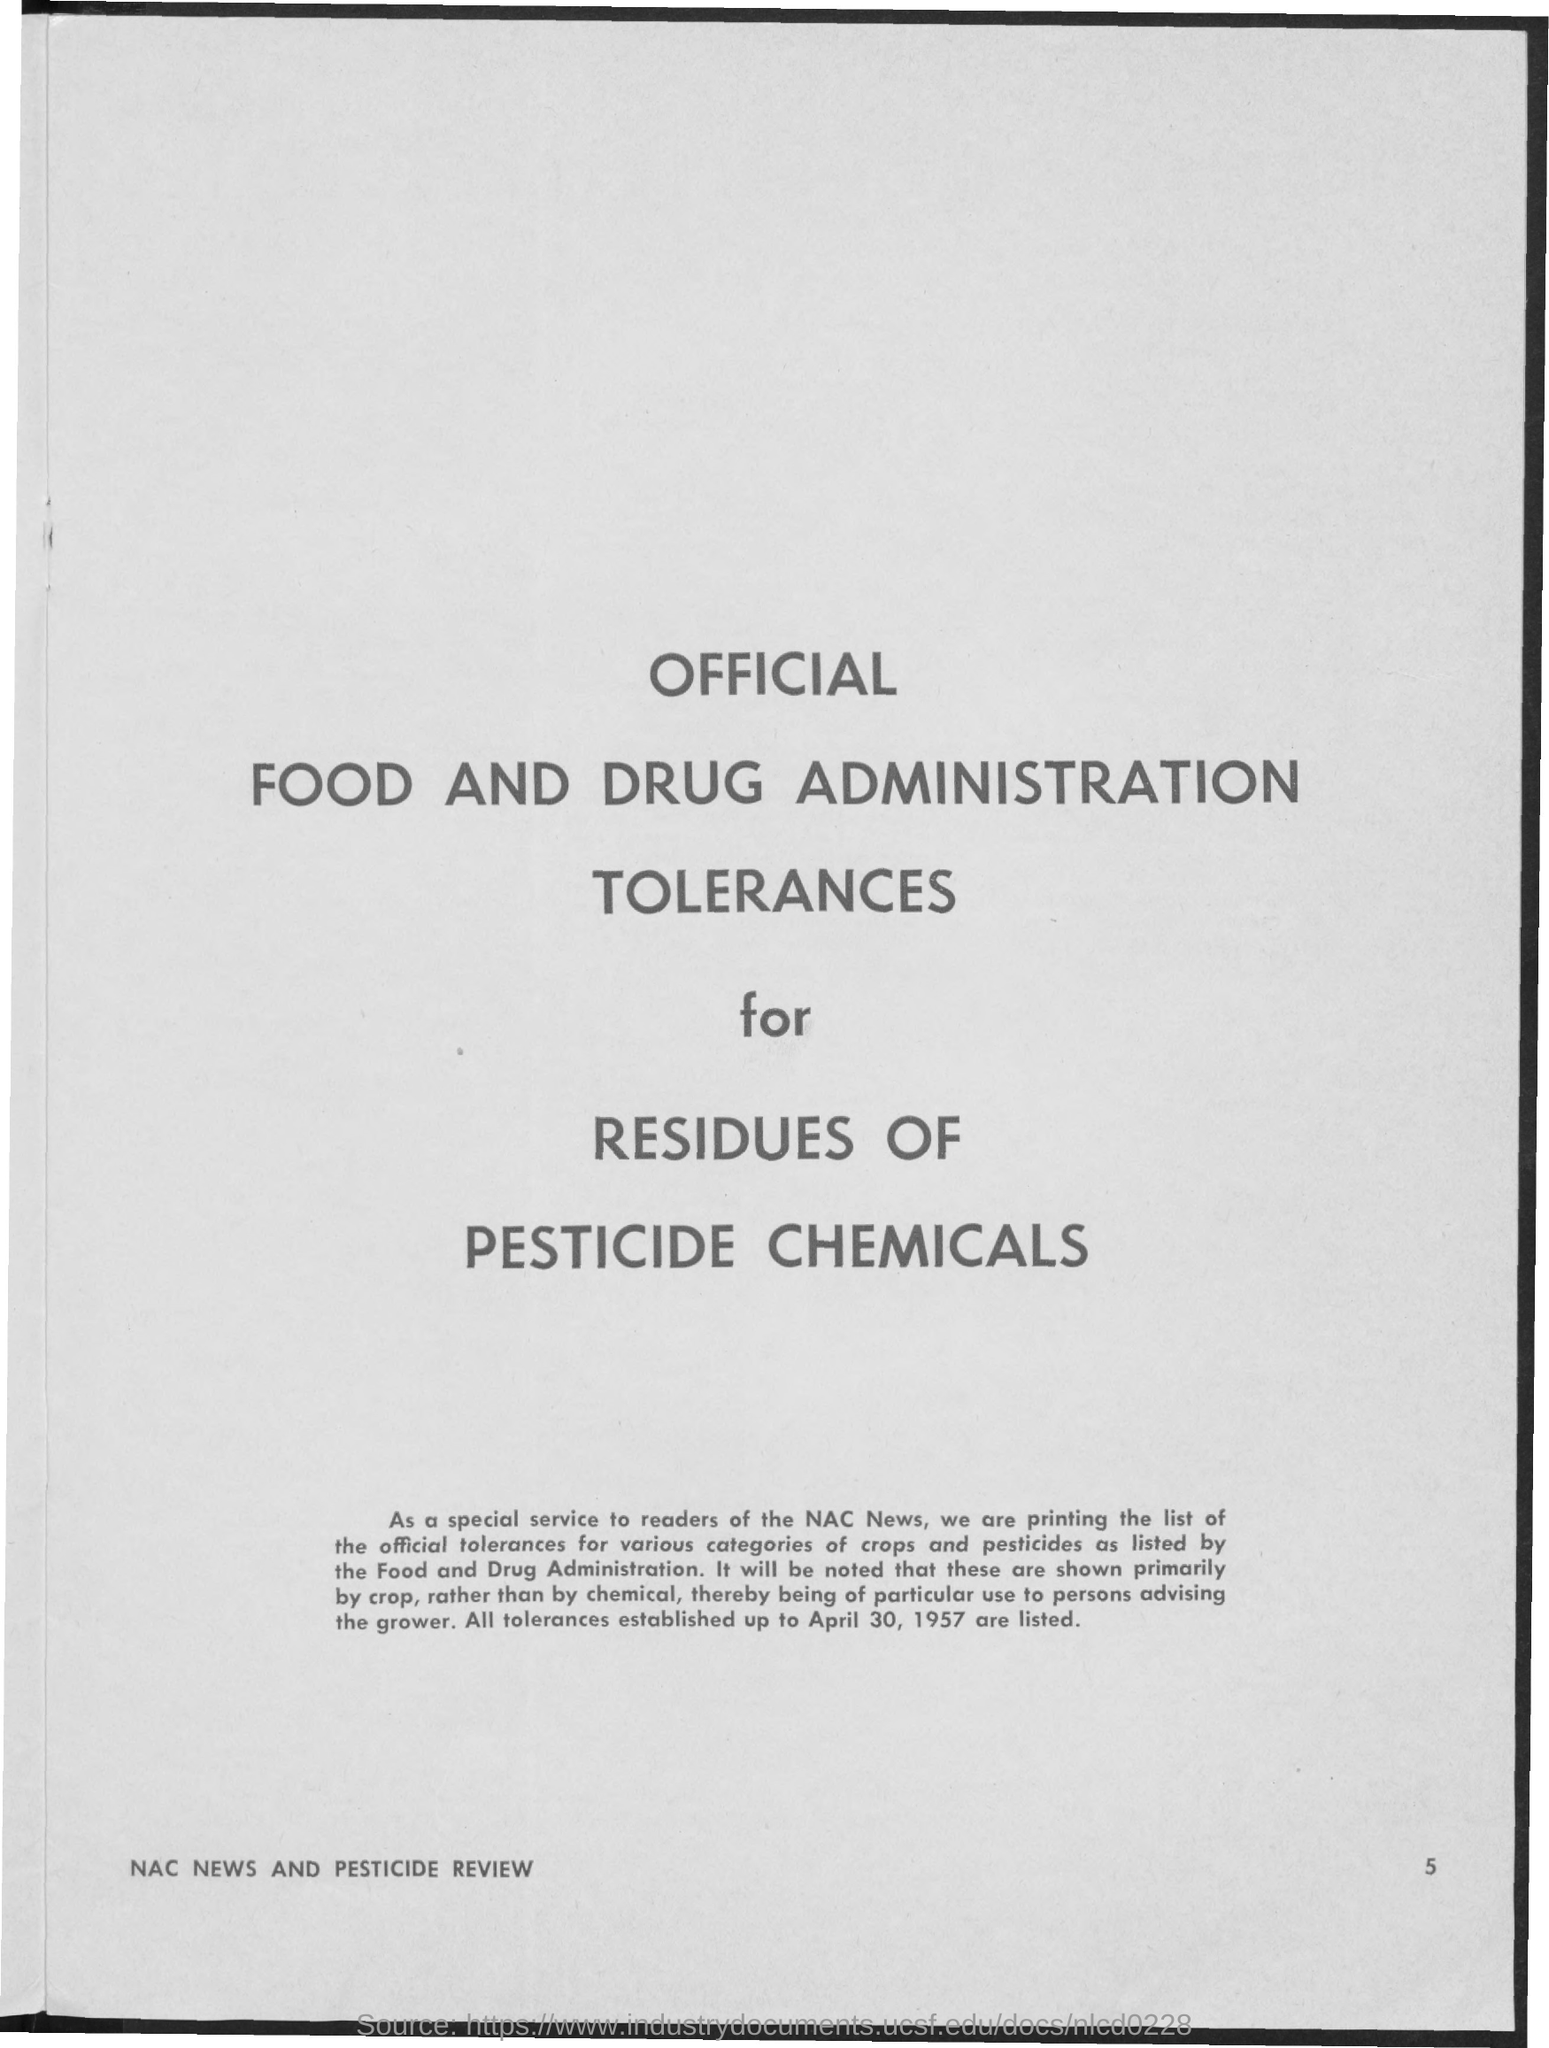Mention a couple of crucial points in this snapshot. The page number is 5. The document in question is titled "Official Food and Drug Administration Tolerances for Residues of Pesticide Chemicals. 